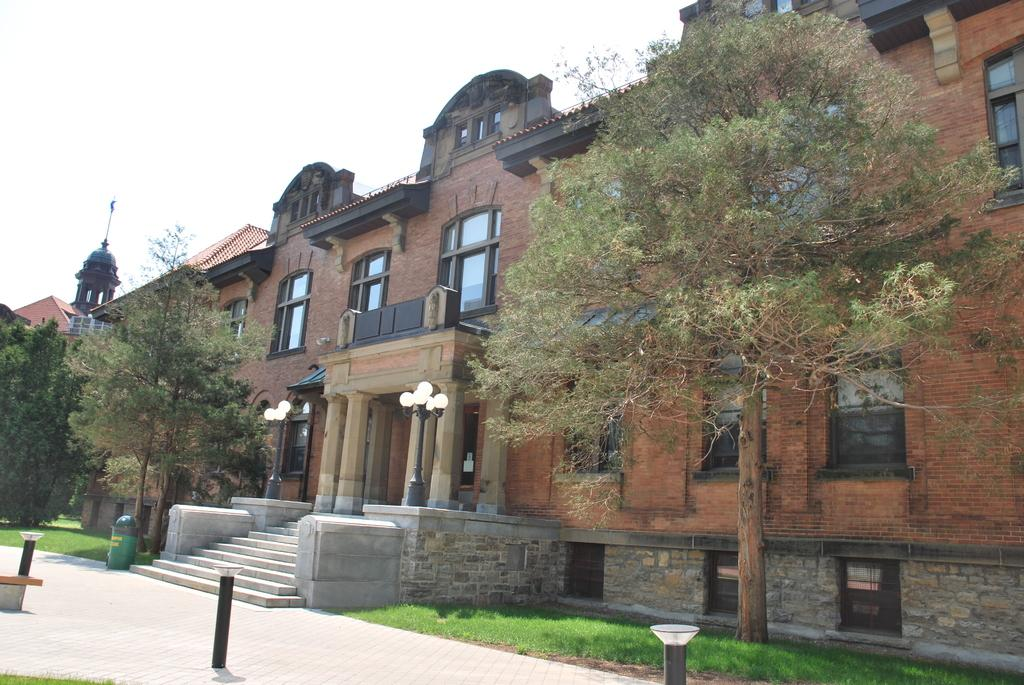What type of structures can be seen in the image? There are buildings in the image. What feature is present on the buildings? There are windows in the image. What type of street furniture is visible in the image? There are light poles in the image. What object is present for waste disposal? There is a dustbin in the image. What type of vegetation is present in the image? There are trees and grass in the image. What part of the natural environment is visible in the image? The sky is visible in the image. How does the image show an increase in the number of light poles over time? The image does not show any changes over time, nor does it provide information about the number of light poles in the past or future. The image only captures a snapshot of the current scene, which includes light poles. 